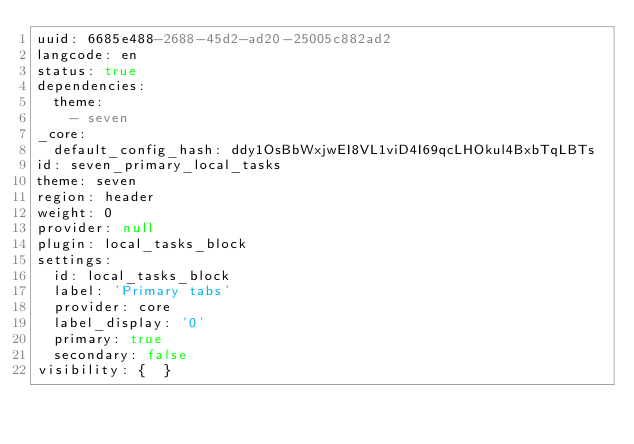Convert code to text. <code><loc_0><loc_0><loc_500><loc_500><_YAML_>uuid: 6685e488-2688-45d2-ad20-25005c882ad2
langcode: en
status: true
dependencies:
  theme:
    - seven
_core:
  default_config_hash: ddy1OsBbWxjwEI8VL1viD4I69qcLHOkul4BxbTqLBTs
id: seven_primary_local_tasks
theme: seven
region: header
weight: 0
provider: null
plugin: local_tasks_block
settings:
  id: local_tasks_block
  label: 'Primary tabs'
  provider: core
  label_display: '0'
  primary: true
  secondary: false
visibility: {  }
</code> 